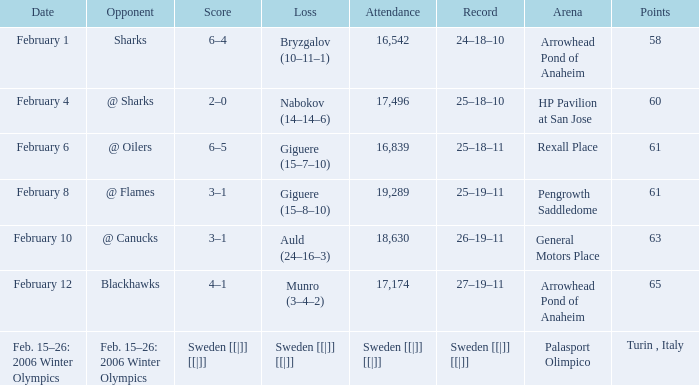What was the record when the score stood at 2-0? 25–18–10. 